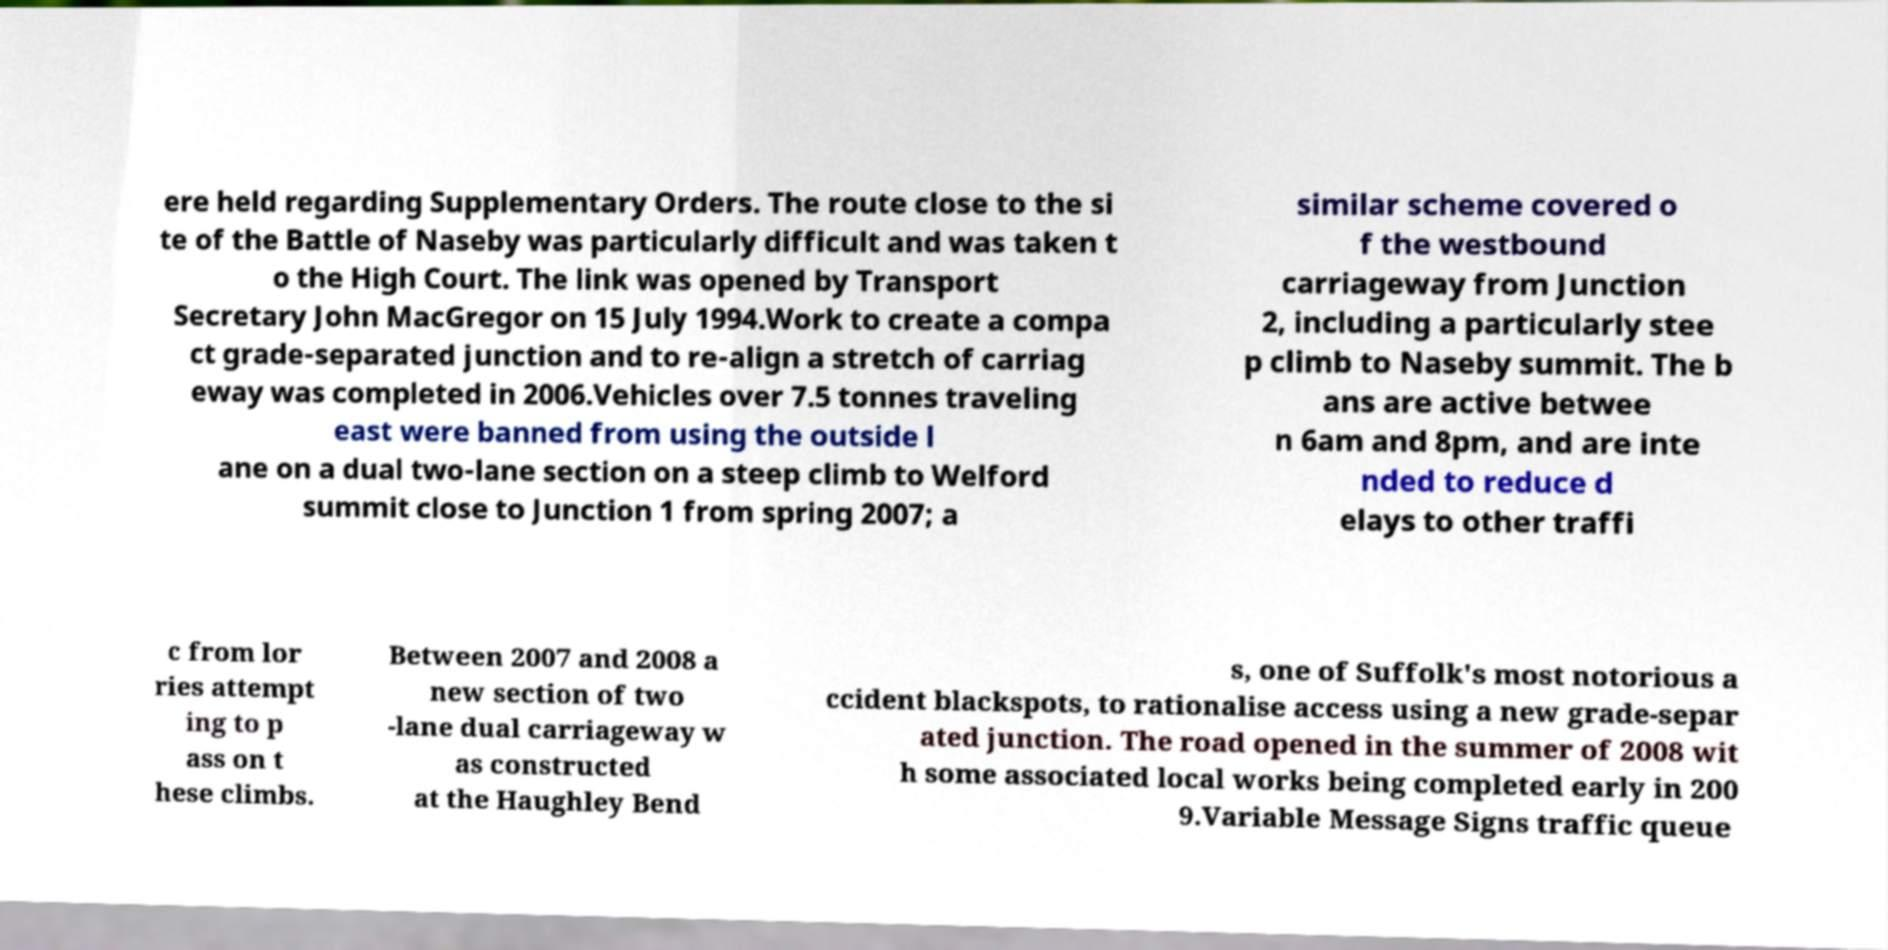There's text embedded in this image that I need extracted. Can you transcribe it verbatim? ere held regarding Supplementary Orders. The route close to the si te of the Battle of Naseby was particularly difficult and was taken t o the High Court. The link was opened by Transport Secretary John MacGregor on 15 July 1994.Work to create a compa ct grade-separated junction and to re-align a stretch of carriag eway was completed in 2006.Vehicles over 7.5 tonnes traveling east were banned from using the outside l ane on a dual two-lane section on a steep climb to Welford summit close to Junction 1 from spring 2007; a similar scheme covered o f the westbound carriageway from Junction 2, including a particularly stee p climb to Naseby summit. The b ans are active betwee n 6am and 8pm, and are inte nded to reduce d elays to other traffi c from lor ries attempt ing to p ass on t hese climbs. Between 2007 and 2008 a new section of two -lane dual carriageway w as constructed at the Haughley Bend s, one of Suffolk's most notorious a ccident blackspots, to rationalise access using a new grade-separ ated junction. The road opened in the summer of 2008 wit h some associated local works being completed early in 200 9.Variable Message Signs traffic queue 